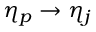Convert formula to latex. <formula><loc_0><loc_0><loc_500><loc_500>\eta _ { p } \rightarrow \eta _ { j }</formula> 